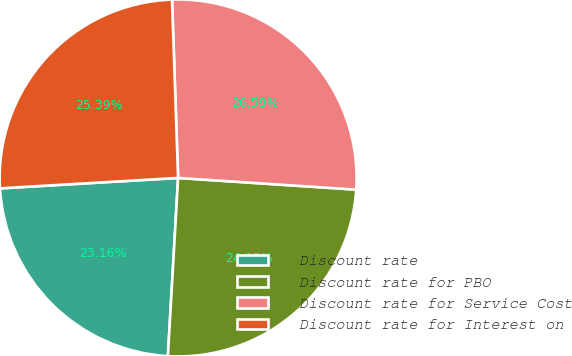<chart> <loc_0><loc_0><loc_500><loc_500><pie_chart><fcel>Discount rate<fcel>Discount rate for PBO<fcel>Discount rate for Service Cost<fcel>Discount rate for Interest on<nl><fcel>23.16%<fcel>24.87%<fcel>26.59%<fcel>25.39%<nl></chart> 